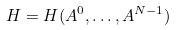Convert formula to latex. <formula><loc_0><loc_0><loc_500><loc_500>H = H ( A ^ { 0 } , \dots , A ^ { N - 1 } )</formula> 